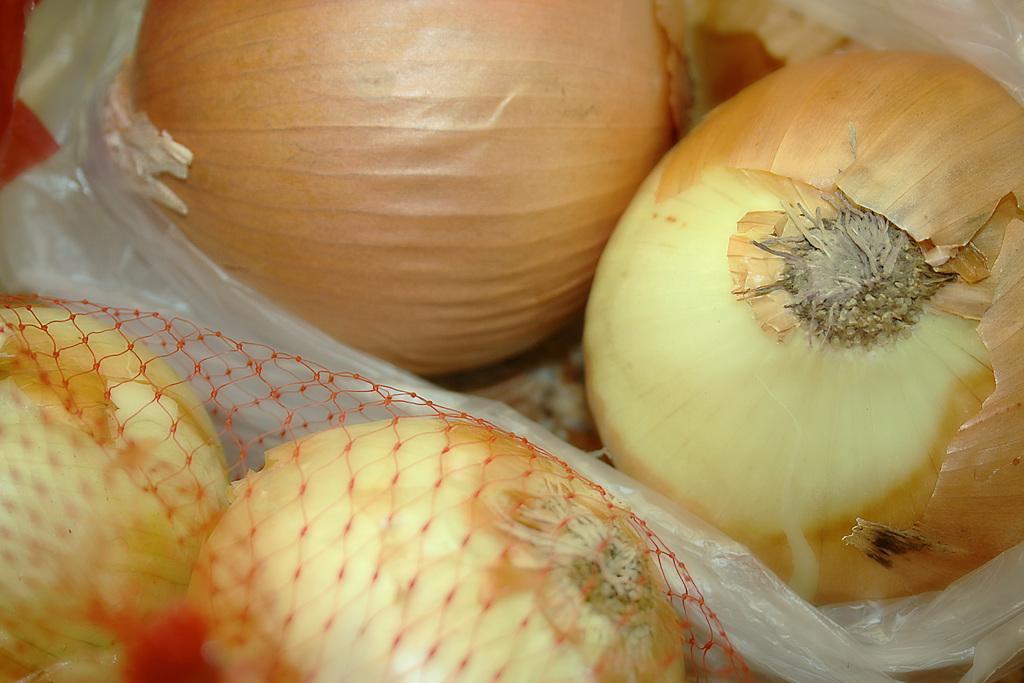Could you give a brief overview of what you see in this image? In this picture I can see onions among them some are in a cover and some are in the red color net. 